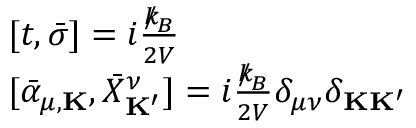<formula> <loc_0><loc_0><loc_500><loc_500>\begin{array} { r l } & { [ t , { \bar { \sigma } } ] = i \frac { { \slash \, k } _ { \, { B } } } { 2 V } } \\ & { [ { \bar { \alpha } } _ { \mu , { K } } , { \bar { X } } _ { K ^ { \prime } } ^ { \nu } ] = i \frac { { \slash \, k } _ { \, { B } } } { 2 V } \delta _ { \mu \nu } \delta _ { { K } { K ^ { \prime } } } } \end{array}</formula> 